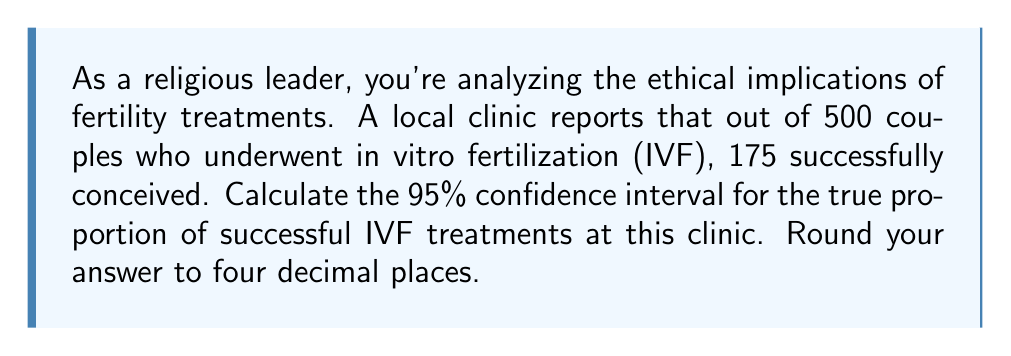Could you help me with this problem? To calculate the confidence interval for a proportion, we'll use the formula:

$$ p \pm z\sqrt{\frac{p(1-p)}{n}} $$

Where:
$p$ = sample proportion
$z$ = z-score for desired confidence level (1.96 for 95% confidence)
$n$ = sample size

Step 1: Calculate the sample proportion (p)
$$ p = \frac{\text{number of successes}}{\text{total sample size}} = \frac{175}{500} = 0.35 $$

Step 2: Calculate the standard error
$$ SE = \sqrt{\frac{p(1-p)}{n}} = \sqrt{\frac{0.35(1-0.35)}{500}} = 0.0213 $$

Step 3: Calculate the margin of error
$$ ME = z \times SE = 1.96 \times 0.0213 = 0.0418 $$

Step 4: Calculate the confidence interval
Lower bound: $0.35 - 0.0418 = 0.3082$
Upper bound: $0.35 + 0.0418 = 0.3918$

Therefore, the 95% confidence interval is (0.3082, 0.3918).
Answer: The 95% confidence interval for the true proportion of successful IVF treatments at this clinic is (0.3082, 0.3918). 